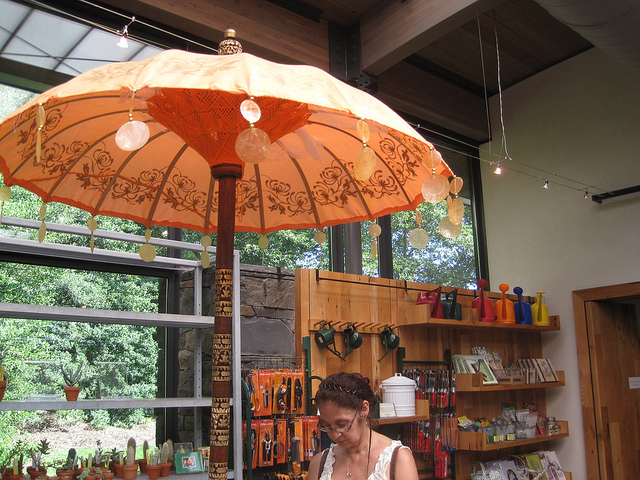<image>Where are the succulents? I am not sure where the succulents are. They could be on a shelf or a window ledge. Where are the succulents? I am not sure where the succulents are. It can be seen on the shelf, in the window or on the window ledge. 